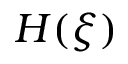<formula> <loc_0><loc_0><loc_500><loc_500>H ( \xi )</formula> 